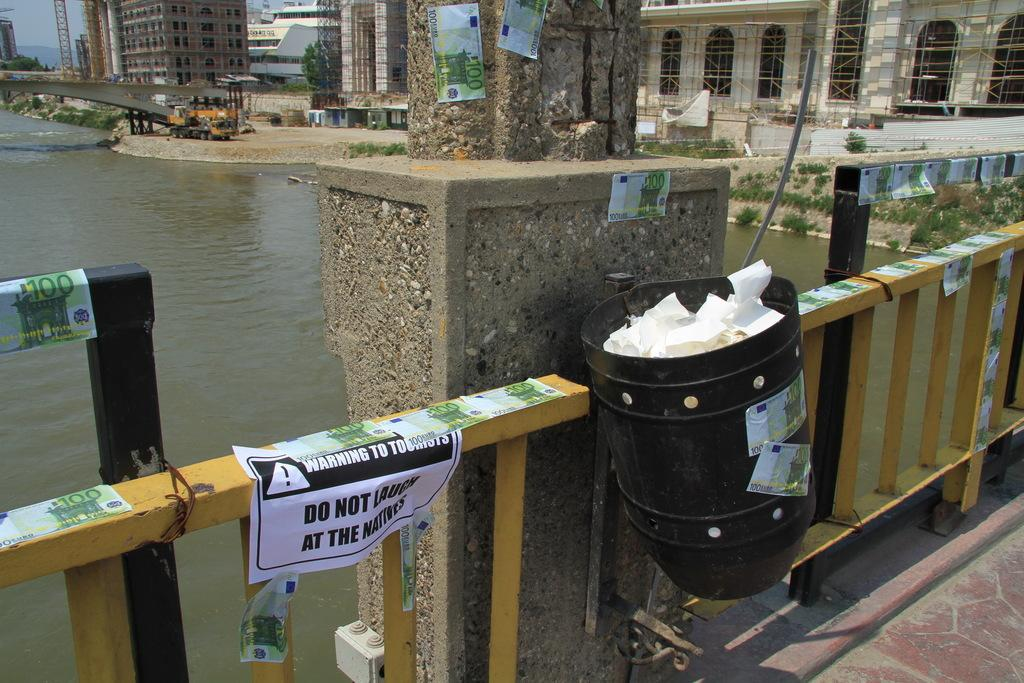<image>
Share a concise interpretation of the image provided. A sign on a fence says Warning to tourists do not laugh at the natives. 